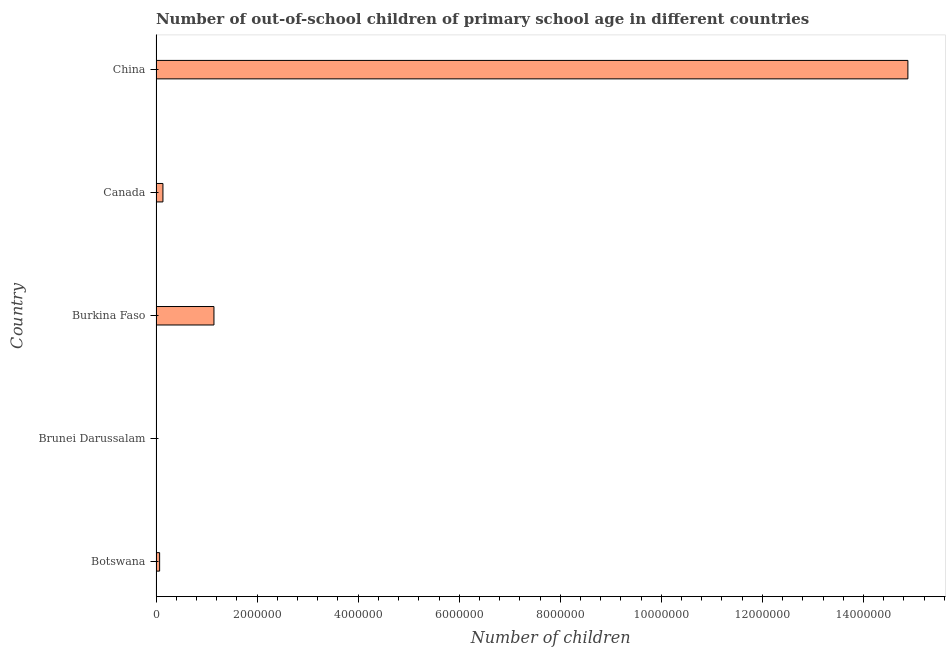What is the title of the graph?
Offer a terse response. Number of out-of-school children of primary school age in different countries. What is the label or title of the X-axis?
Give a very brief answer. Number of children. What is the label or title of the Y-axis?
Provide a short and direct response. Country. What is the number of out-of-school children in China?
Your answer should be very brief. 1.49e+07. Across all countries, what is the maximum number of out-of-school children?
Ensure brevity in your answer.  1.49e+07. Across all countries, what is the minimum number of out-of-school children?
Offer a terse response. 439. In which country was the number of out-of-school children minimum?
Your answer should be very brief. Brunei Darussalam. What is the sum of the number of out-of-school children?
Your response must be concise. 1.62e+07. What is the difference between the number of out-of-school children in Burkina Faso and Canada?
Offer a very short reply. 1.01e+06. What is the average number of out-of-school children per country?
Ensure brevity in your answer.  3.25e+06. What is the median number of out-of-school children?
Your answer should be very brief. 1.37e+05. What is the ratio of the number of out-of-school children in Botswana to that in Canada?
Your answer should be compact. 0.52. What is the difference between the highest and the second highest number of out-of-school children?
Provide a succinct answer. 1.37e+07. Is the sum of the number of out-of-school children in Canada and China greater than the maximum number of out-of-school children across all countries?
Provide a short and direct response. Yes. What is the difference between the highest and the lowest number of out-of-school children?
Make the answer very short. 1.49e+07. In how many countries, is the number of out-of-school children greater than the average number of out-of-school children taken over all countries?
Your answer should be very brief. 1. Are all the bars in the graph horizontal?
Offer a very short reply. Yes. Are the values on the major ticks of X-axis written in scientific E-notation?
Offer a very short reply. No. What is the Number of children of Botswana?
Ensure brevity in your answer.  7.12e+04. What is the Number of children of Brunei Darussalam?
Ensure brevity in your answer.  439. What is the Number of children in Burkina Faso?
Ensure brevity in your answer.  1.15e+06. What is the Number of children in Canada?
Make the answer very short. 1.37e+05. What is the Number of children of China?
Provide a short and direct response. 1.49e+07. What is the difference between the Number of children in Botswana and Brunei Darussalam?
Offer a terse response. 7.07e+04. What is the difference between the Number of children in Botswana and Burkina Faso?
Your answer should be compact. -1.08e+06. What is the difference between the Number of children in Botswana and Canada?
Ensure brevity in your answer.  -6.56e+04. What is the difference between the Number of children in Botswana and China?
Keep it short and to the point. -1.48e+07. What is the difference between the Number of children in Brunei Darussalam and Burkina Faso?
Your response must be concise. -1.15e+06. What is the difference between the Number of children in Brunei Darussalam and Canada?
Give a very brief answer. -1.36e+05. What is the difference between the Number of children in Brunei Darussalam and China?
Provide a short and direct response. -1.49e+07. What is the difference between the Number of children in Burkina Faso and Canada?
Provide a succinct answer. 1.01e+06. What is the difference between the Number of children in Burkina Faso and China?
Your response must be concise. -1.37e+07. What is the difference between the Number of children in Canada and China?
Your answer should be compact. -1.47e+07. What is the ratio of the Number of children in Botswana to that in Brunei Darussalam?
Keep it short and to the point. 162.1. What is the ratio of the Number of children in Botswana to that in Burkina Faso?
Make the answer very short. 0.06. What is the ratio of the Number of children in Botswana to that in Canada?
Give a very brief answer. 0.52. What is the ratio of the Number of children in Botswana to that in China?
Provide a succinct answer. 0.01. What is the ratio of the Number of children in Brunei Darussalam to that in Canada?
Offer a terse response. 0. What is the ratio of the Number of children in Burkina Faso to that in Canada?
Your answer should be compact. 8.38. What is the ratio of the Number of children in Burkina Faso to that in China?
Provide a succinct answer. 0.08. What is the ratio of the Number of children in Canada to that in China?
Ensure brevity in your answer.  0.01. 